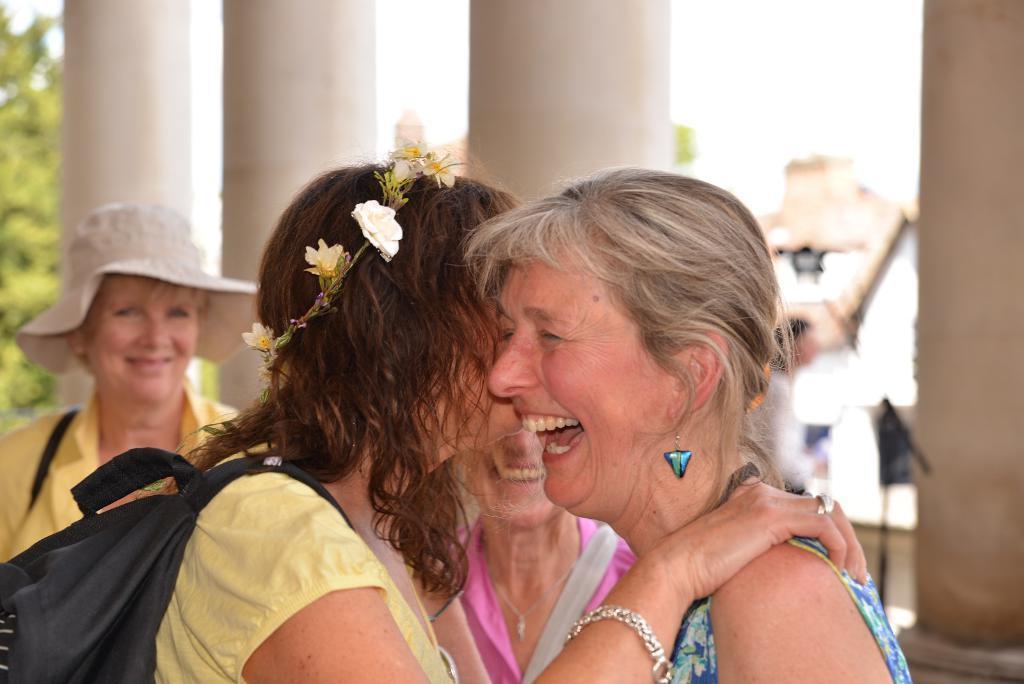How would you summarize this image in a sentence or two? This woman wore crown and bag. Another woman is smiling. Background it is blurry and we can see pillars, tree and people. 